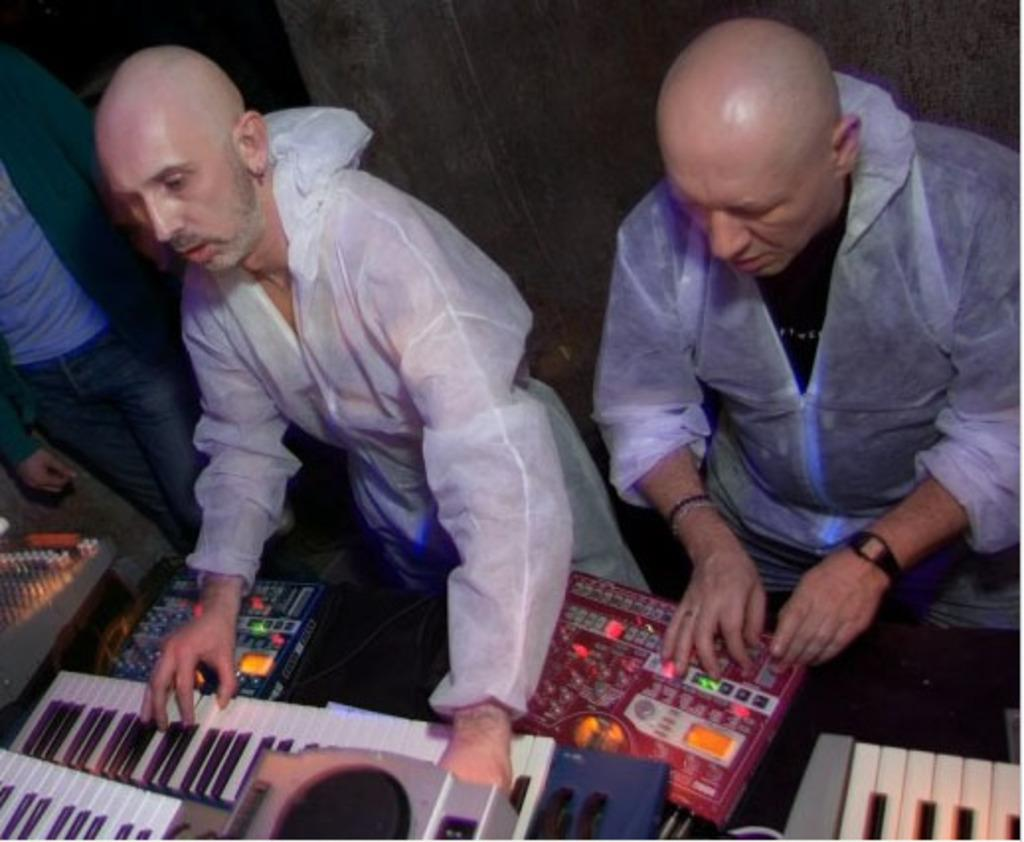How many people are seated in the image? There are two men seated in the image. What is one of the men doing in the image? There is a man playing the piano in the image. What is the position of the other man in the image? There is another man standing on the side in the image. What type of yak can be seen in the image? There is no yak present in the image. What kind of bun is being served to the men in the image? There is no mention of any bun being served in the image. 